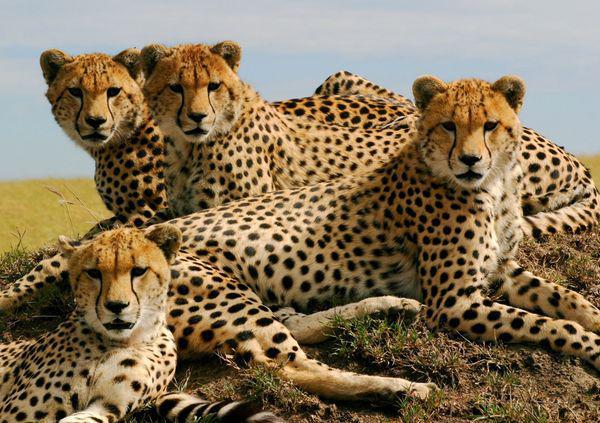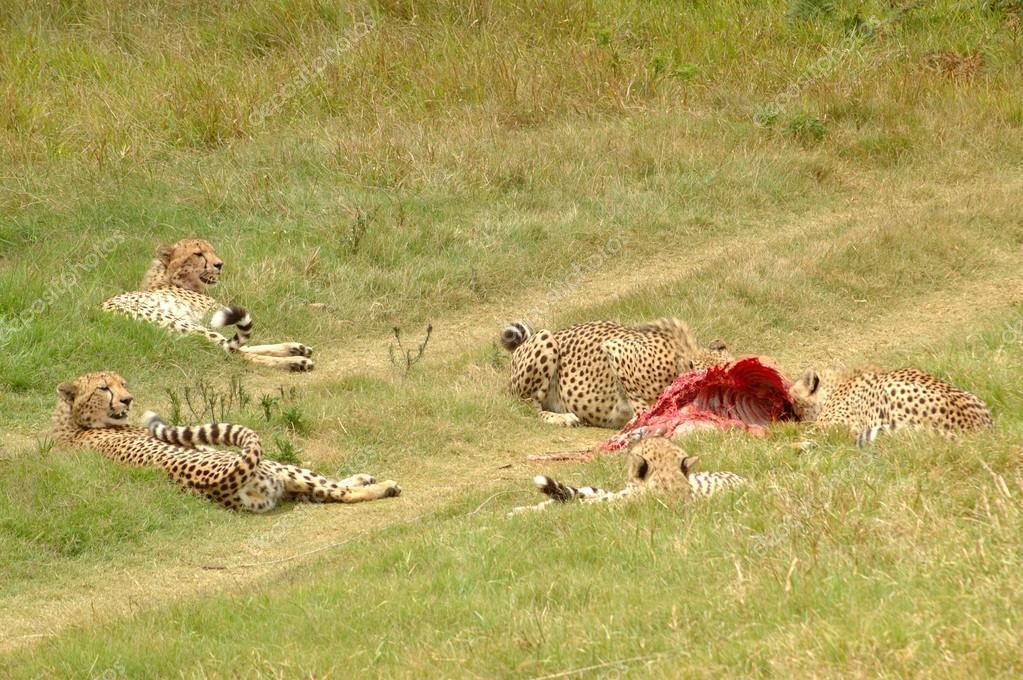The first image is the image on the left, the second image is the image on the right. Assess this claim about the two images: "Four leopards are laying on a dirt patch in a yellow-green field in one of the images.". Correct or not? Answer yes or no. No. 